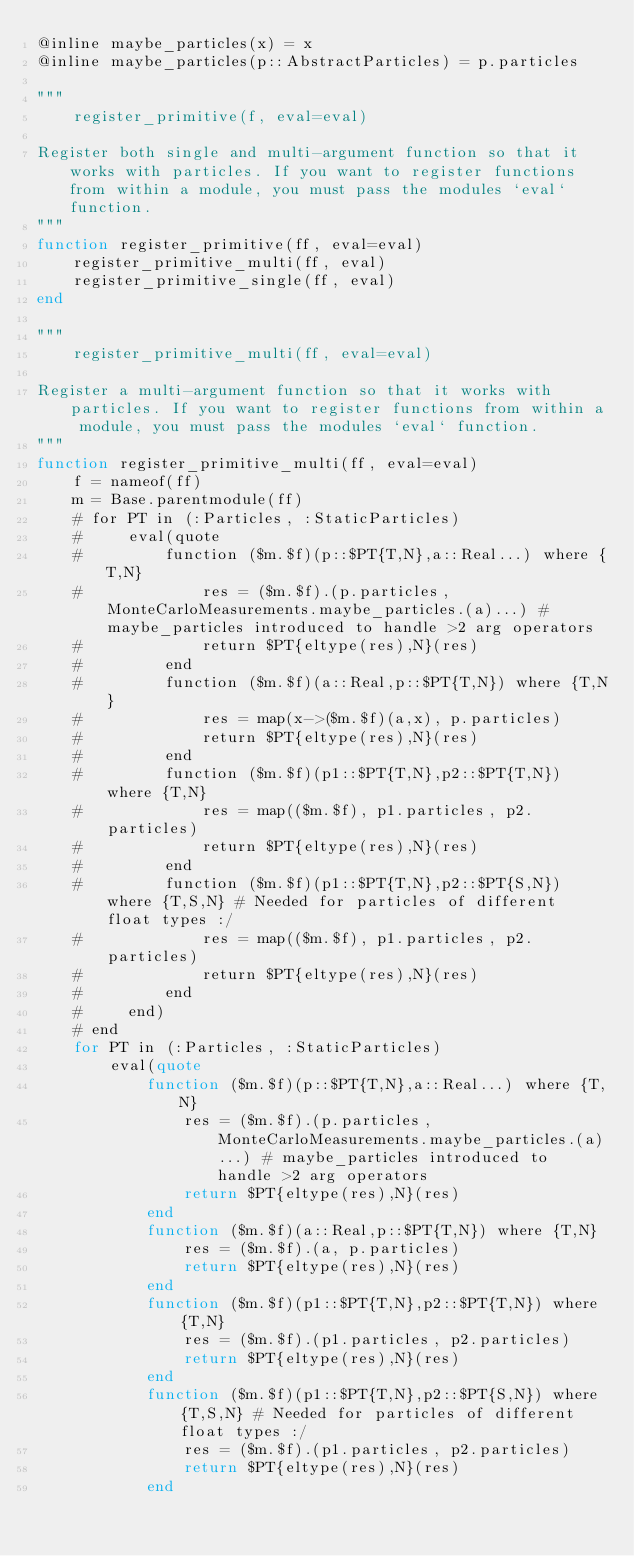Convert code to text. <code><loc_0><loc_0><loc_500><loc_500><_Julia_>@inline maybe_particles(x) = x
@inline maybe_particles(p::AbstractParticles) = p.particles

"""
    register_primitive(f, eval=eval)

Register both single and multi-argument function so that it works with particles. If you want to register functions from within a module, you must pass the modules `eval` function.
"""
function register_primitive(ff, eval=eval)
    register_primitive_multi(ff, eval)
    register_primitive_single(ff, eval)
end

"""
    register_primitive_multi(ff, eval=eval)

Register a multi-argument function so that it works with particles. If you want to register functions from within a module, you must pass the modules `eval` function.
"""
function register_primitive_multi(ff, eval=eval)
    f = nameof(ff)
    m = Base.parentmodule(ff)
    # for PT in (:Particles, :StaticParticles)
    #     eval(quote
    #         function ($m.$f)(p::$PT{T,N},a::Real...) where {T,N}
    #             res = ($m.$f).(p.particles, MonteCarloMeasurements.maybe_particles.(a)...) # maybe_particles introduced to handle >2 arg operators
    #             return $PT{eltype(res),N}(res)
    #         end
    #         function ($m.$f)(a::Real,p::$PT{T,N}) where {T,N}
    #             res = map(x->($m.$f)(a,x), p.particles)
    #             return $PT{eltype(res),N}(res)
    #         end
    #         function ($m.$f)(p1::$PT{T,N},p2::$PT{T,N}) where {T,N}
    #             res = map(($m.$f), p1.particles, p2.particles)
    #             return $PT{eltype(res),N}(res)
    #         end
    #         function ($m.$f)(p1::$PT{T,N},p2::$PT{S,N}) where {T,S,N} # Needed for particles of different float types :/
    #             res = map(($m.$f), p1.particles, p2.particles)
    #             return $PT{eltype(res),N}(res)
    #         end
    #     end)
    # end
    for PT in (:Particles, :StaticParticles)
        eval(quote
            function ($m.$f)(p::$PT{T,N},a::Real...) where {T,N}
                res = ($m.$f).(p.particles, MonteCarloMeasurements.maybe_particles.(a)...) # maybe_particles introduced to handle >2 arg operators
                return $PT{eltype(res),N}(res)
            end
            function ($m.$f)(a::Real,p::$PT{T,N}) where {T,N}
                res = ($m.$f).(a, p.particles)
                return $PT{eltype(res),N}(res)
            end
            function ($m.$f)(p1::$PT{T,N},p2::$PT{T,N}) where {T,N}
                res = ($m.$f).(p1.particles, p2.particles)
                return $PT{eltype(res),N}(res)
            end
            function ($m.$f)(p1::$PT{T,N},p2::$PT{S,N}) where {T,S,N} # Needed for particles of different float types :/
                res = ($m.$f).(p1.particles, p2.particles)
                return $PT{eltype(res),N}(res)
            end</code> 